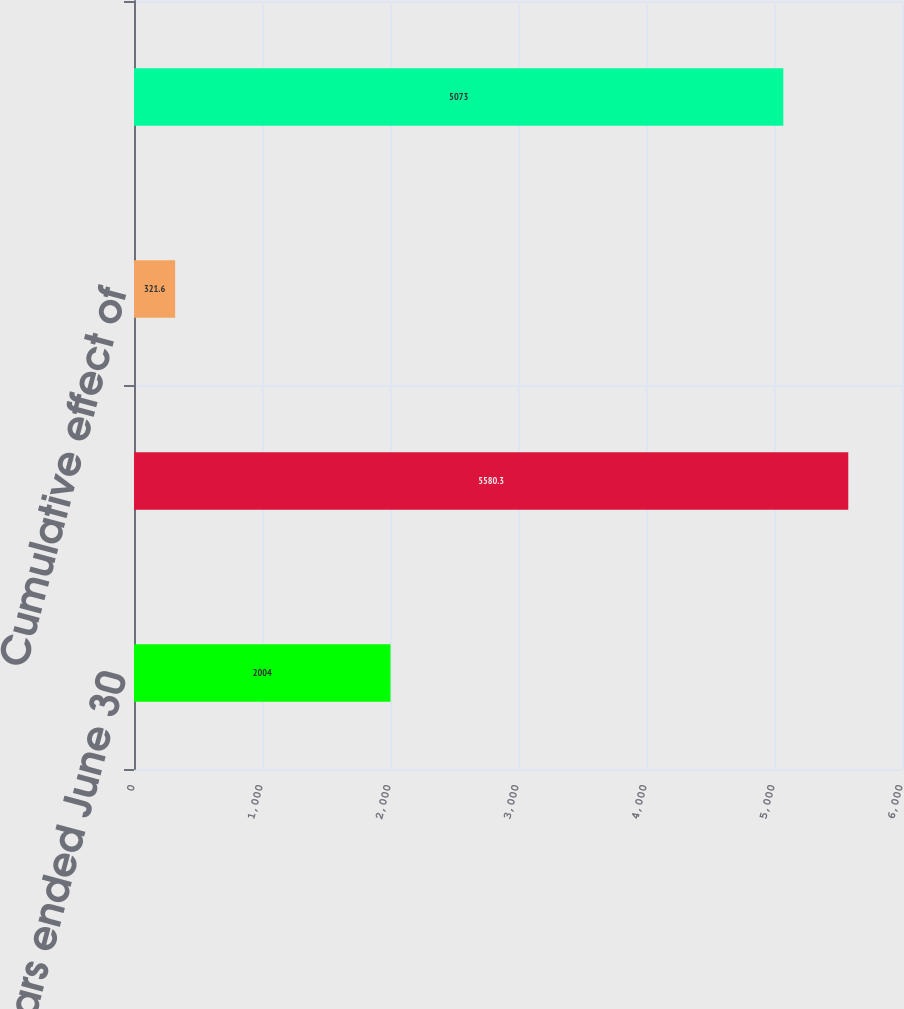Convert chart. <chart><loc_0><loc_0><loc_500><loc_500><bar_chart><fcel>Years ended June 30<fcel>Average total stockholders'<fcel>Cumulative effect of<fcel>Average total equity excluding<nl><fcel>2004<fcel>5580.3<fcel>321.6<fcel>5073<nl></chart> 